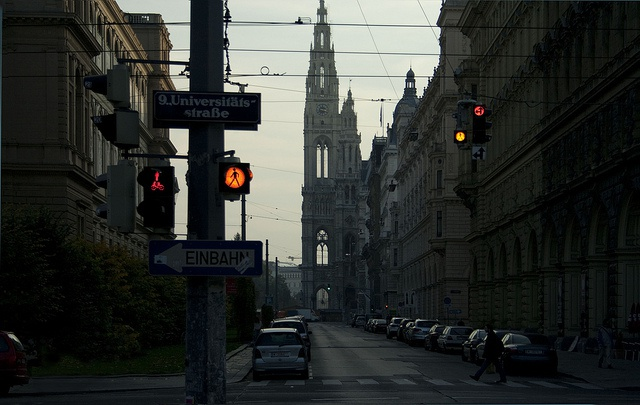Describe the objects in this image and their specific colors. I can see traffic light in black and gray tones, car in black, darkblue, and gray tones, traffic light in black and darkblue tones, car in black, gray, and purple tones, and traffic light in black, brown, gray, and maroon tones in this image. 